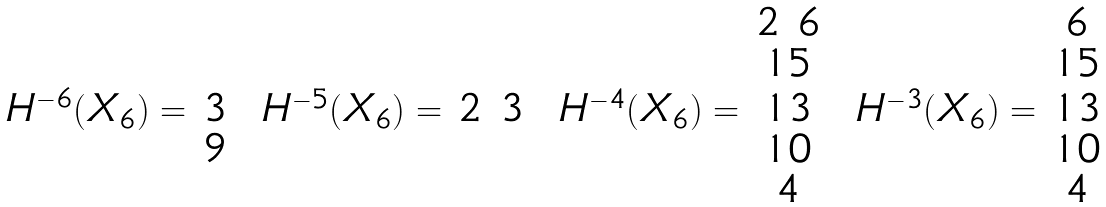<formula> <loc_0><loc_0><loc_500><loc_500>\begin{array} { c c } & \\ & \\ H ^ { - 6 } ( X _ { 6 } ) = & 3 \\ & 9 \\ & \\ \end{array} \ \begin{array} { c c } & \\ & \\ H ^ { - 5 } ( X _ { 6 } ) = & 2 \ 3 \\ & \\ & \\ \end{array} \ \begin{array} { c c } & 2 \ 6 \\ & 1 5 \\ H ^ { - 4 } ( X _ { 6 } ) = & 1 3 \\ & 1 0 \\ & 4 \\ \end{array} \ \begin{array} { c c } & 6 \\ & 1 5 \\ H ^ { - 3 } ( X _ { 6 } ) = & 1 3 \\ & 1 0 \\ & 4 \\ \end{array}</formula> 